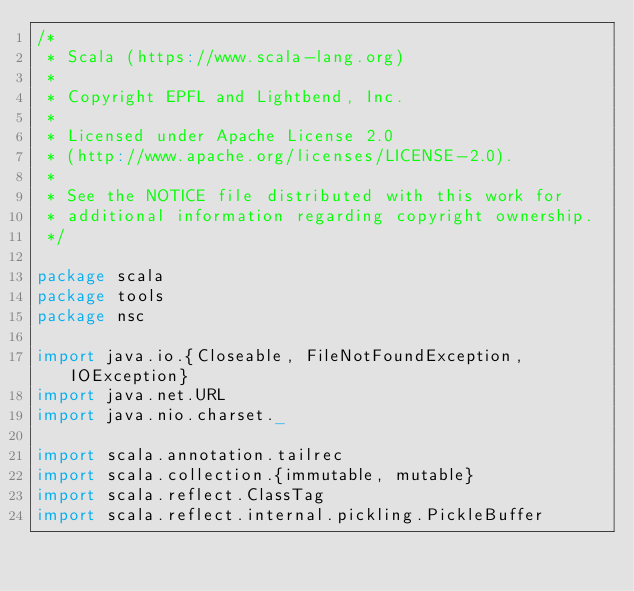Convert code to text. <code><loc_0><loc_0><loc_500><loc_500><_Scala_>/*
 * Scala (https://www.scala-lang.org)
 *
 * Copyright EPFL and Lightbend, Inc.
 *
 * Licensed under Apache License 2.0
 * (http://www.apache.org/licenses/LICENSE-2.0).
 *
 * See the NOTICE file distributed with this work for
 * additional information regarding copyright ownership.
 */

package scala
package tools
package nsc

import java.io.{Closeable, FileNotFoundException, IOException}
import java.net.URL
import java.nio.charset._

import scala.annotation.tailrec
import scala.collection.{immutable, mutable}
import scala.reflect.ClassTag
import scala.reflect.internal.pickling.PickleBuffer</code> 